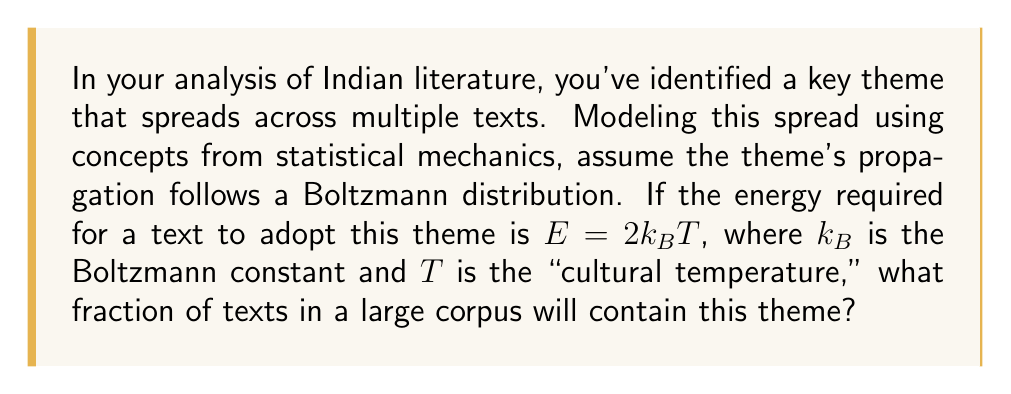Can you solve this math problem? To solve this problem, we'll use the Boltzmann distribution from statistical mechanics to model the spread of literary themes:

1) The Boltzmann distribution gives the probability of a system being in a state with energy $E$:

   $$P(E) = \frac{1}{Z} e^{-E/k_BT}$$

   where $Z$ is the partition function.

2) In this case, we're interested in the fraction of texts that adopt the theme (let's call this state 1) versus those that don't (state 0). We can treat this as a two-state system.

3) For state 1 (theme adopted), $E_1 = 2k_BT$. For state 0 (theme not adopted), we can set $E_0 = 0$ as a reference point.

4) The partition function $Z$ is the sum of Boltzmann factors for all states:

   $$Z = e^{-E_0/k_BT} + e^{-E_1/k_BT} = 1 + e^{-2}$$

5) The probability of a text adopting the theme (being in state 1) is:

   $$P(E_1) = \frac{1}{Z} e^{-E_1/k_BT} = \frac{e^{-2}}{1 + e^{-2}}$$

6) To simplify this fraction:

   $$P(E_1) = \frac{1}{e^2 + 1}$$

7) This probability represents the fraction of texts in a large corpus that will contain the theme.
Answer: $\frac{1}{e^2 + 1}$ 